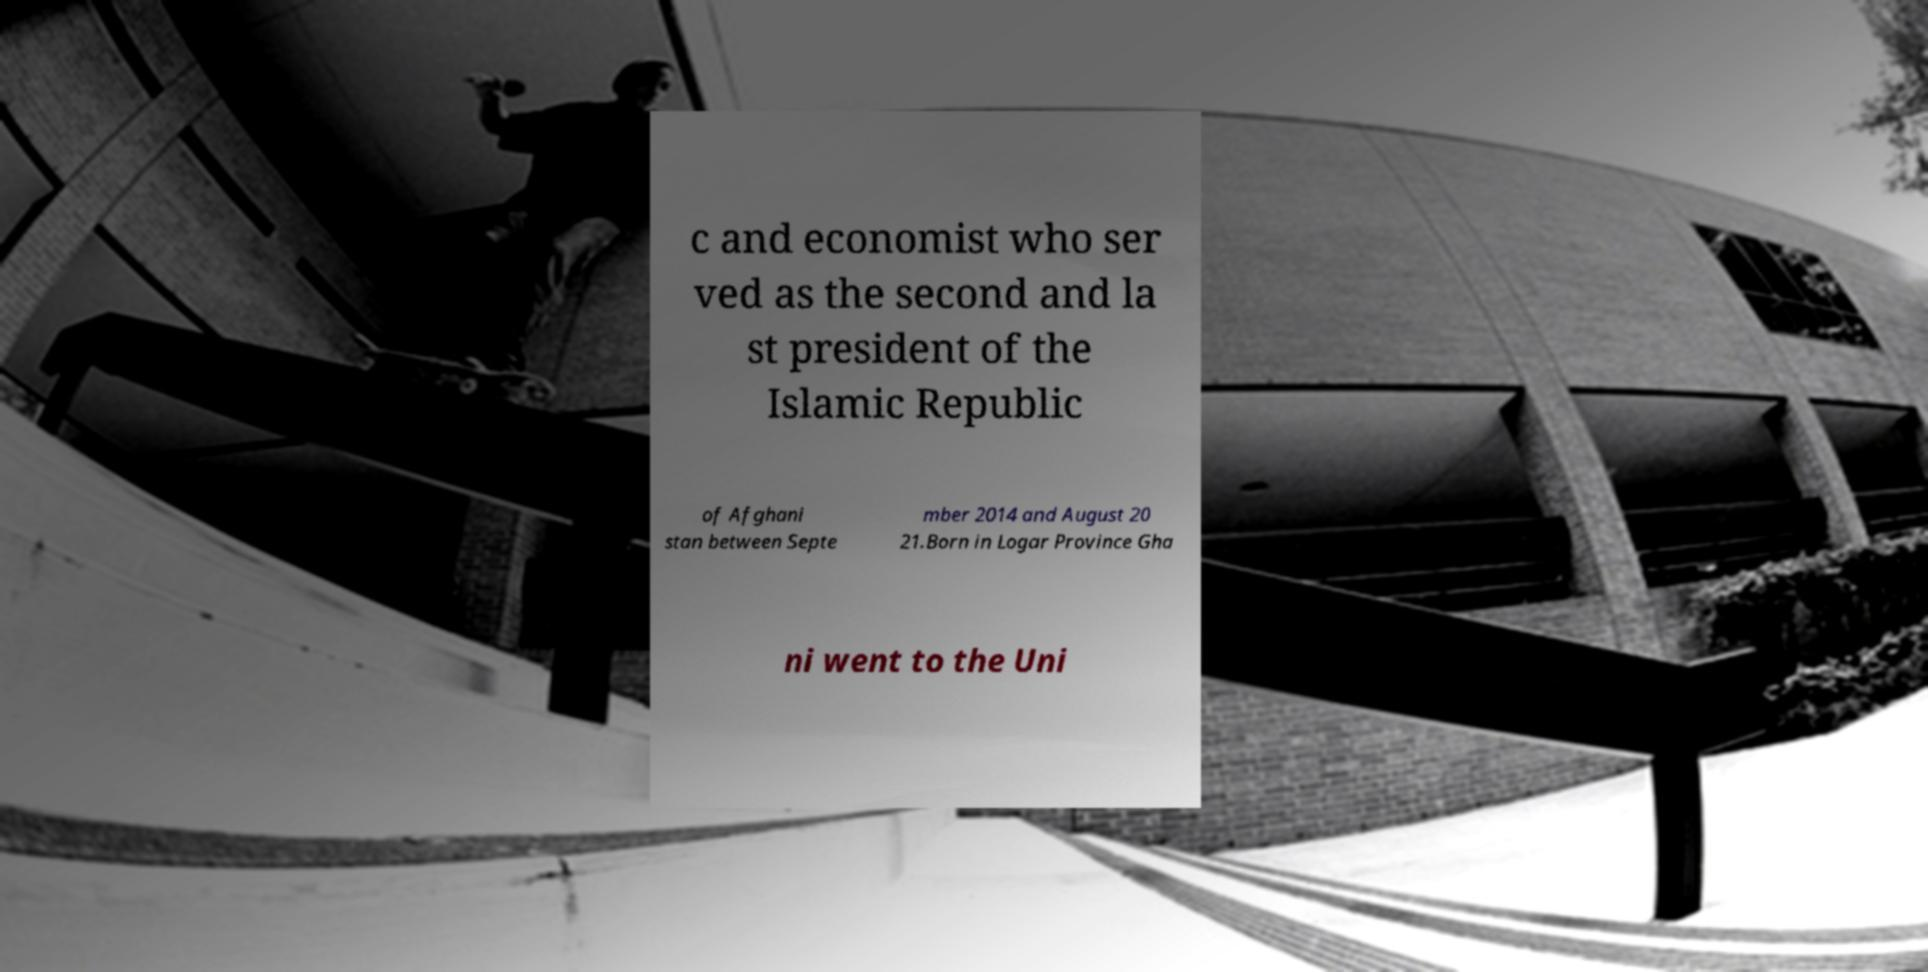There's text embedded in this image that I need extracted. Can you transcribe it verbatim? c and economist who ser ved as the second and la st president of the Islamic Republic of Afghani stan between Septe mber 2014 and August 20 21.Born in Logar Province Gha ni went to the Uni 